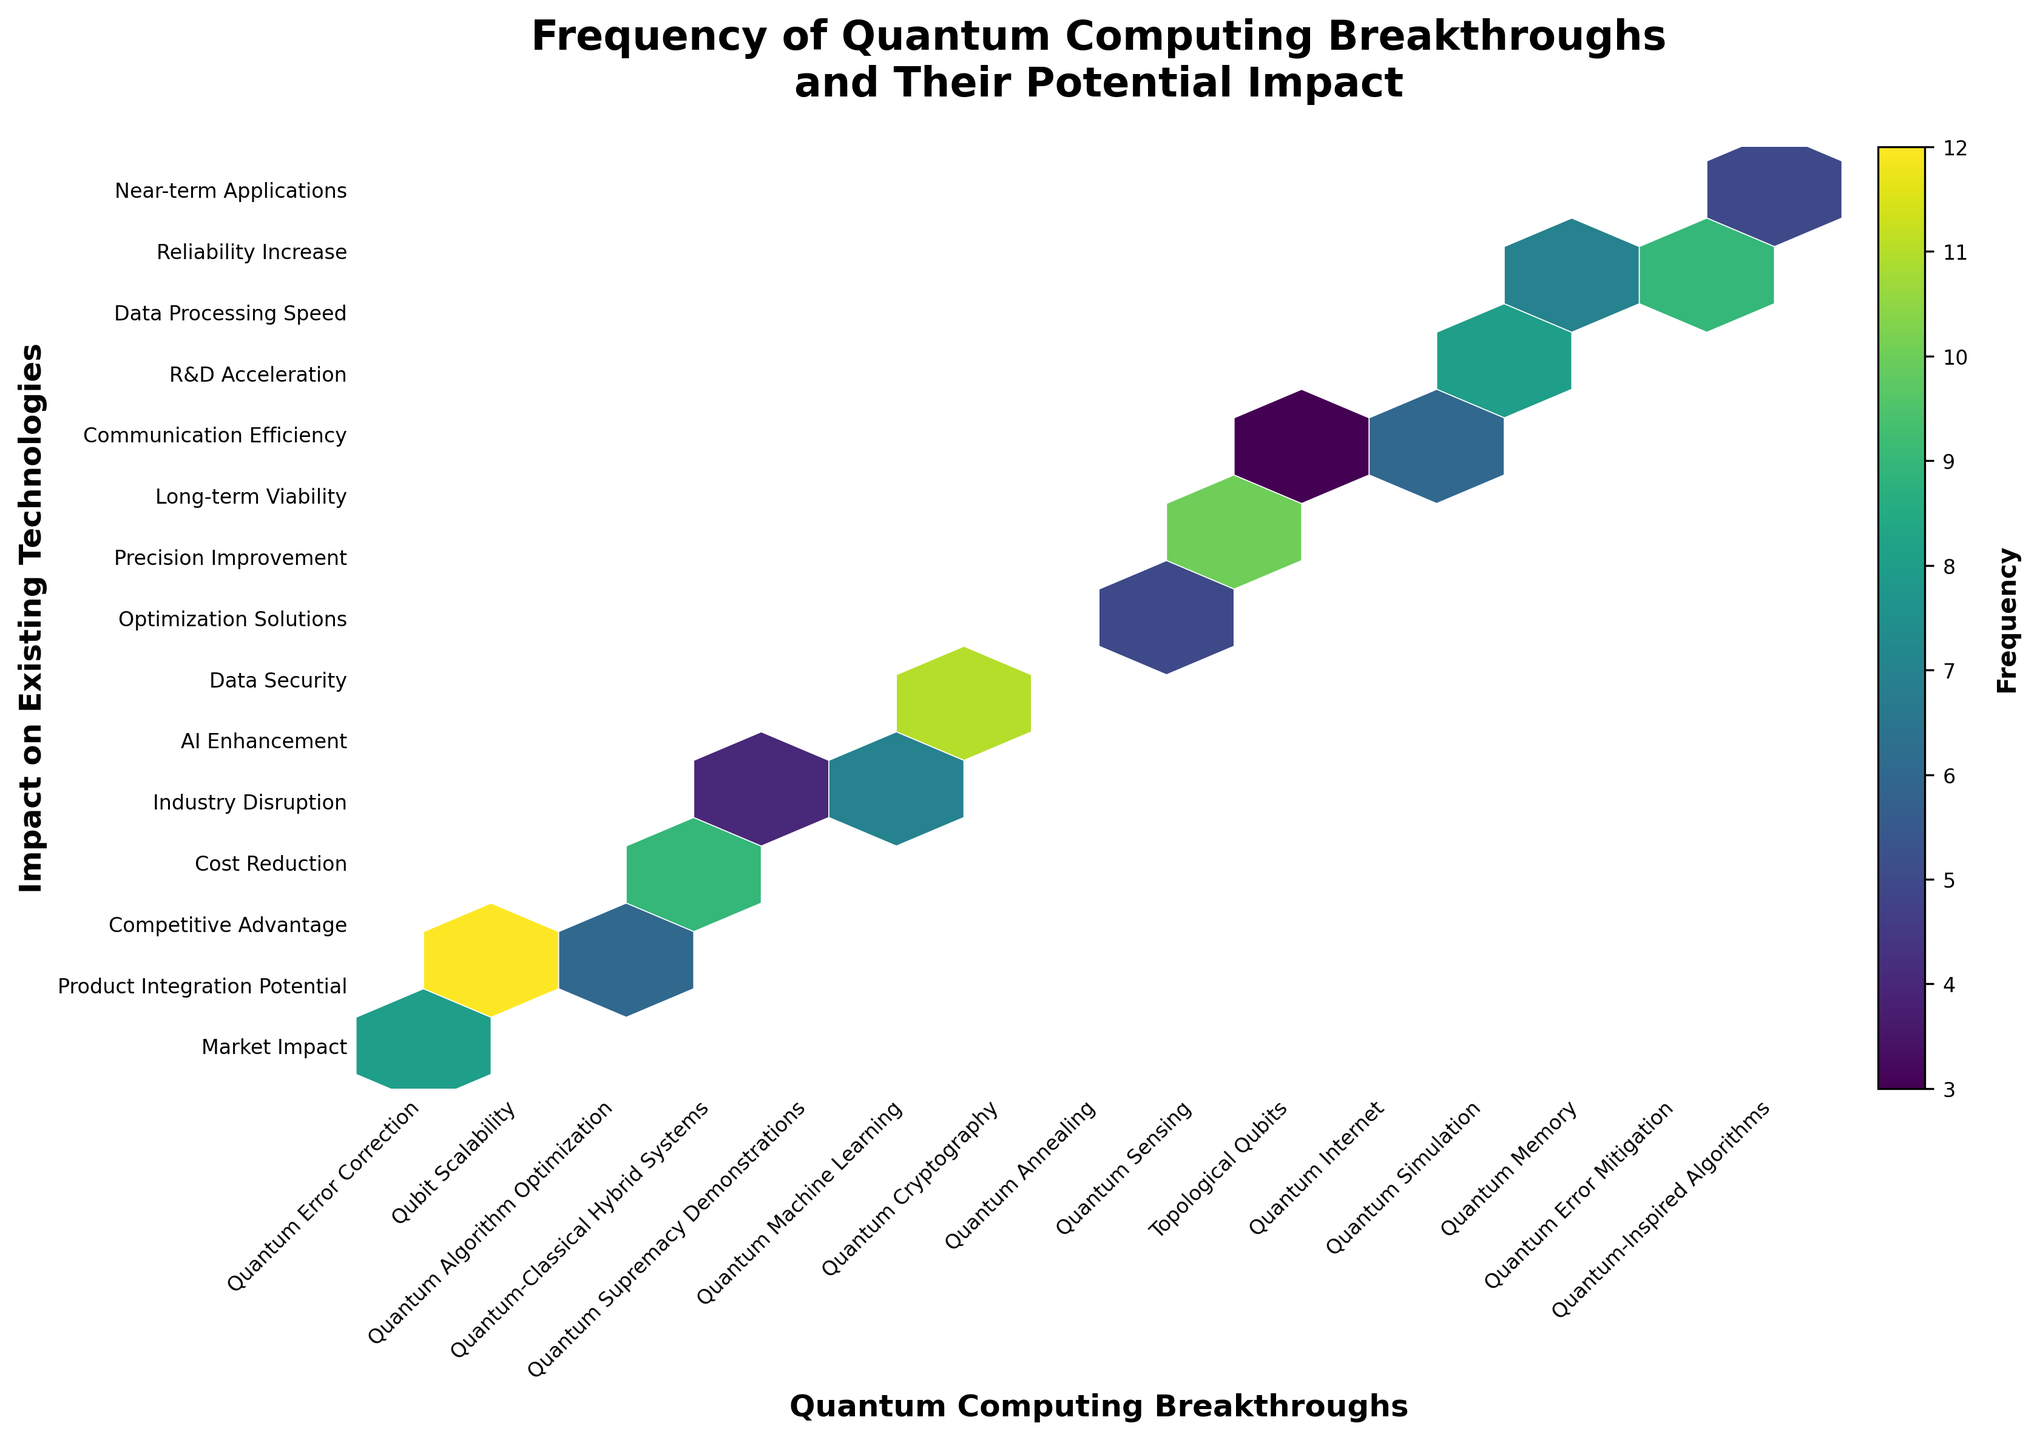Which breakthrough has the highest frequency? The hexbin plot shows the grid's color intensity indicating frequency. The brightest hexbin corresponds to 'Qubit Scalability' in 'Product Integration Potential' area.
Answer: Qubit Scalability What is the title of the plot? The title is usually placed at the top of the figure and is clearly written in bold.
Answer: Frequency of Quantum Computing Breakthroughs and Their Potential Impact How many breakthroughs have a frequency higher than 9? By inspecting the color bar and matching the highest color intensities in the hexbin plot, you can see there are three such breakthroughs: 'Qubit Scalability,' 'Quantum Cryptography,' and 'Quantum Sensing.'
Answer: 3 Which impact area has the lowest frequency associated with a breakthrough? By checking the color intensities, the faintest hexbin corresponds to 'Long-term Viability,' associated with 'Topological Qubits.'
Answer: Long-term Viability What is the x-axis label? The x-axis label is located below the axis itself and describes what the horizontal dimension represents.
Answer: Quantum Computing Breakthroughs Between 'Quantum Algorithm Optimization' and 'Quantum Internet,' which one has a higher frequency? Comparing the color intensities in the hexbin plot, 'Quantum Algorithm Optimization' and 'Quantum Internet' both have frequencies matching with 6. Reviewing this alignment confirms no difference.
Answer: Both are equal Which breakthroughs fall under the 'Industry Disruption' impact area, and what are their frequencies? 'Industry Disruption' is on the y-axis. The corresponding breakthrough in the x-axis is 'Quantum Supremacy Demonstrations' with a frequency found in the color bar matching with the hexbin plot.
Answer: Quantum Supremacy Demonstrations, 4 What's the average frequency of all the breakthroughs? Summing up all frequencies and dividing by the number of breakthroughs gives (8+12+6+9+4+7+11+5+10+3+6+8+7+9+5)/15 = 100/15 = 6.67.
Answer: 6.67 